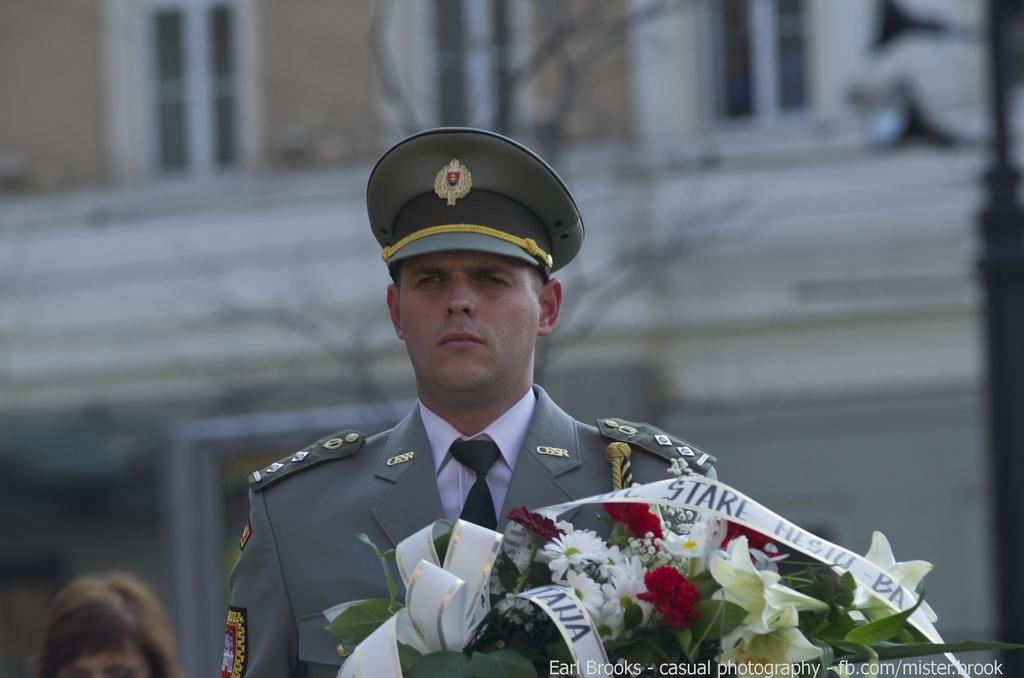Please provide a concise description of this image. In the foreground of this image, there is a man with a bouquet in his hand. In the background, there is a head of a person on left bottom corner. In the background, we see a building and few windows. 